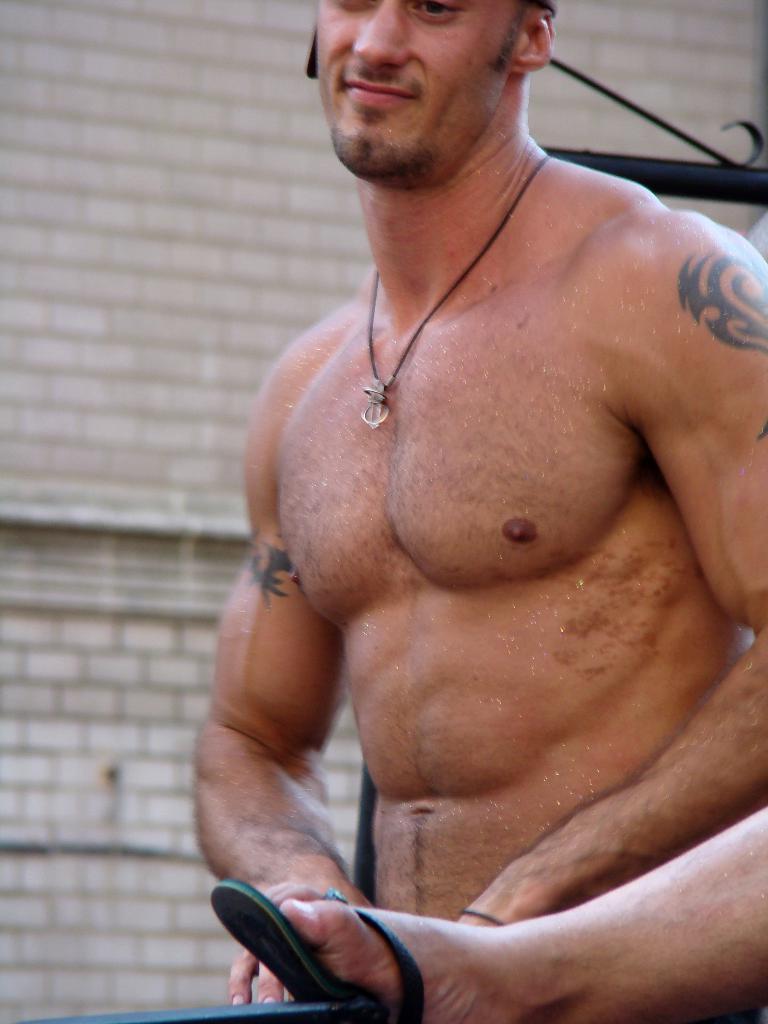Could you give a brief overview of what you see in this image? In this image we can see a man. Also we can see leg of a person. In the back there is a wall. 